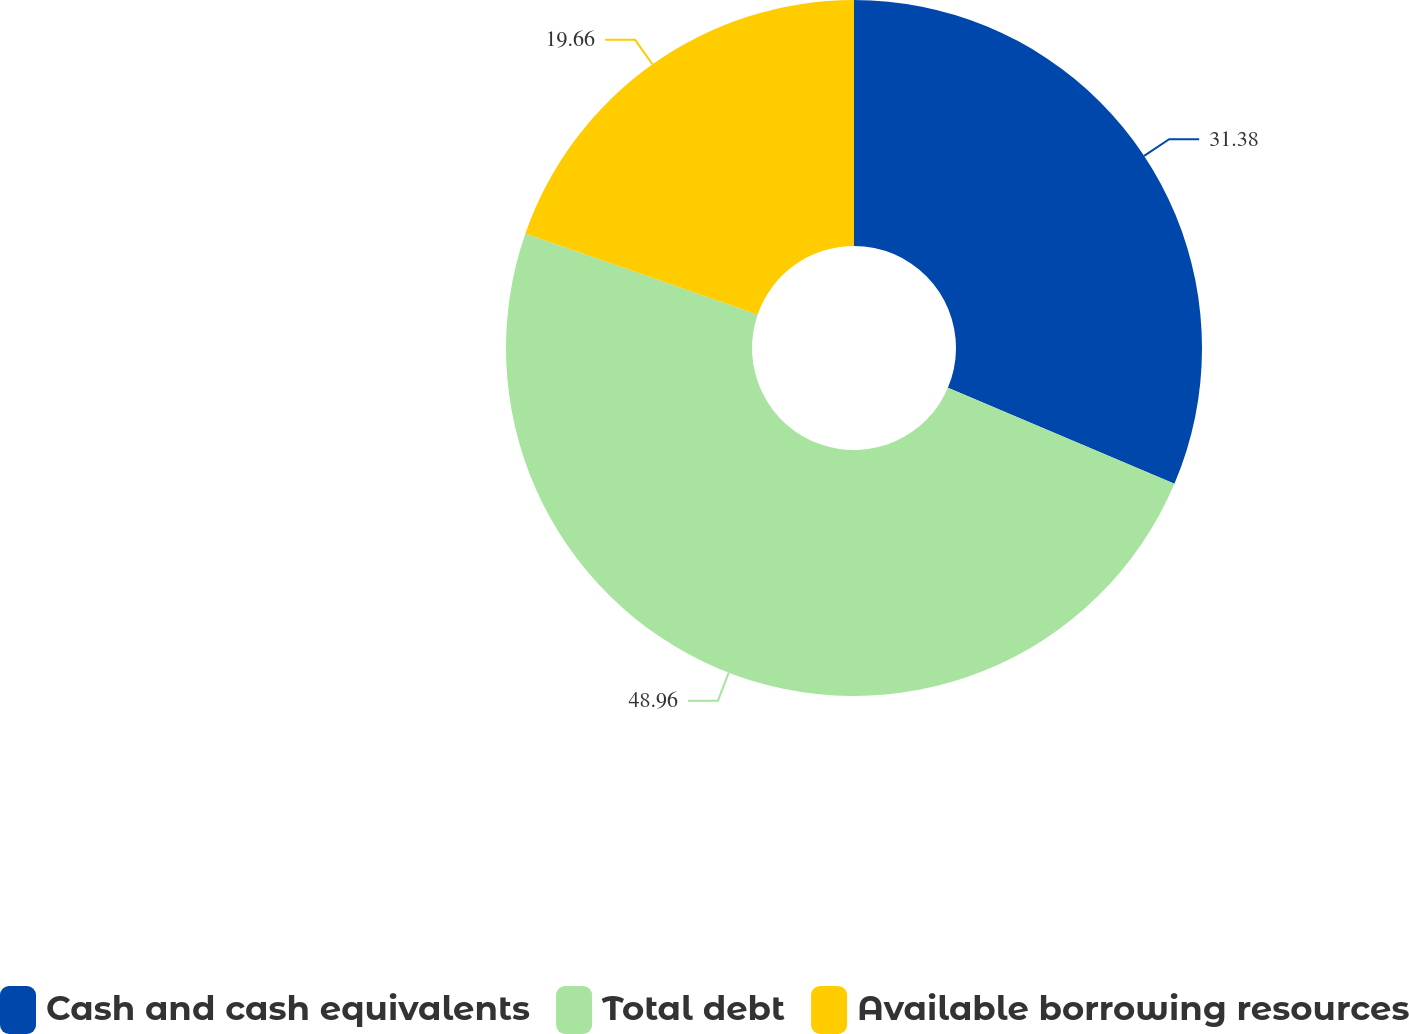Convert chart. <chart><loc_0><loc_0><loc_500><loc_500><pie_chart><fcel>Cash and cash equivalents<fcel>Total debt<fcel>Available borrowing resources<nl><fcel>31.38%<fcel>48.96%<fcel>19.66%<nl></chart> 